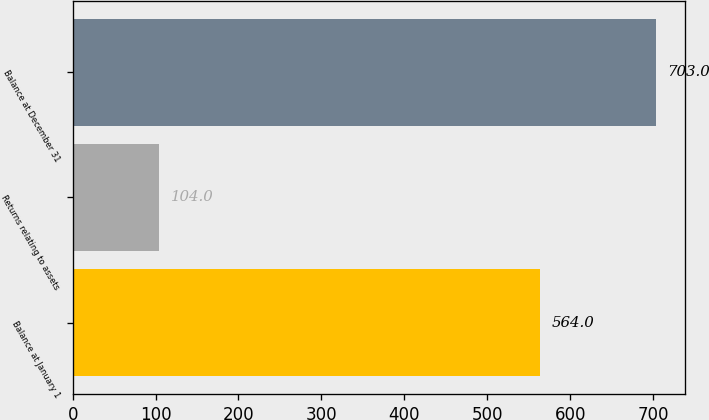<chart> <loc_0><loc_0><loc_500><loc_500><bar_chart><fcel>Balance at January 1<fcel>Returns relating to assets<fcel>Balance at December 31<nl><fcel>564<fcel>104<fcel>703<nl></chart> 